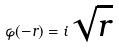<formula> <loc_0><loc_0><loc_500><loc_500>\varphi ( - r ) = i \sqrt { r }</formula> 